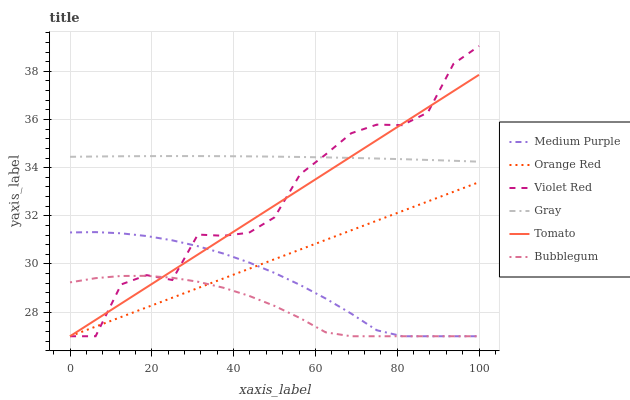Does Bubblegum have the minimum area under the curve?
Answer yes or no. Yes. Does Gray have the maximum area under the curve?
Answer yes or no. Yes. Does Violet Red have the minimum area under the curve?
Answer yes or no. No. Does Violet Red have the maximum area under the curve?
Answer yes or no. No. Is Tomato the smoothest?
Answer yes or no. Yes. Is Violet Red the roughest?
Answer yes or no. Yes. Is Gray the smoothest?
Answer yes or no. No. Is Gray the roughest?
Answer yes or no. No. Does Tomato have the lowest value?
Answer yes or no. Yes. Does Gray have the lowest value?
Answer yes or no. No. Does Violet Red have the highest value?
Answer yes or no. Yes. Does Gray have the highest value?
Answer yes or no. No. Is Orange Red less than Gray?
Answer yes or no. Yes. Is Gray greater than Medium Purple?
Answer yes or no. Yes. Does Orange Red intersect Bubblegum?
Answer yes or no. Yes. Is Orange Red less than Bubblegum?
Answer yes or no. No. Is Orange Red greater than Bubblegum?
Answer yes or no. No. Does Orange Red intersect Gray?
Answer yes or no. No. 